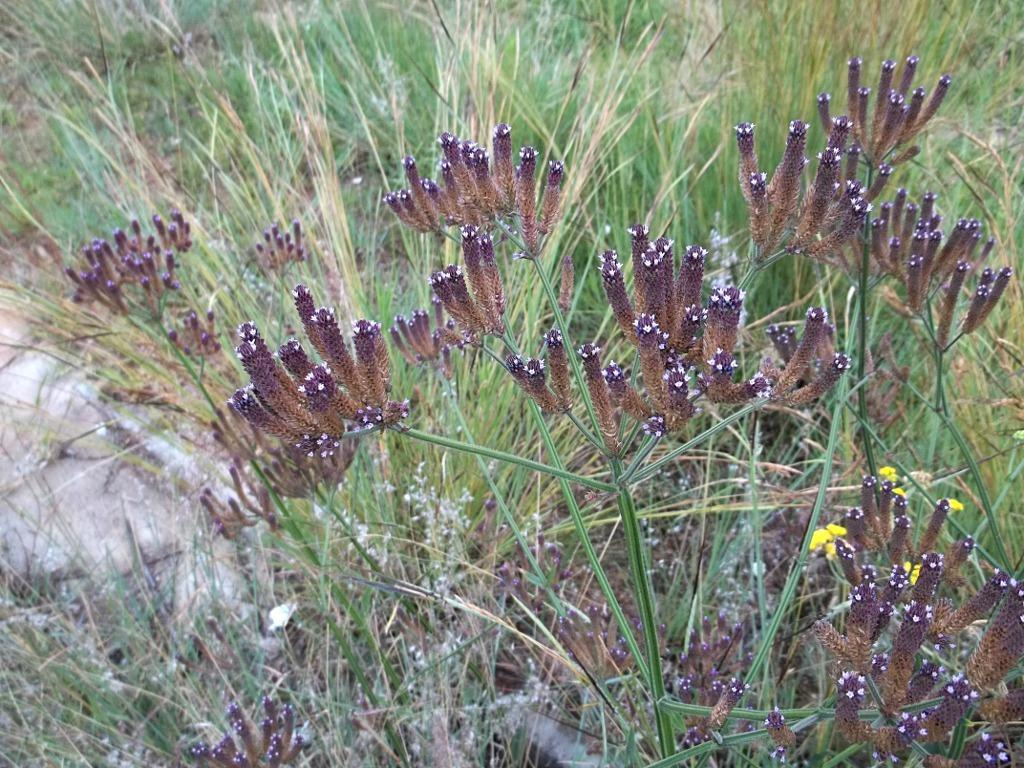What type of vegetation is present in the image? There is grass in the image. What other natural elements can be seen in the image? There are flowers in the image. What colors are the flowers? The flowers are pink, brown, white, and yellow in color. Where is the white-colored object located in the image? The white-colored object is on the left side of the image. How does the sand interact with the tramp in the image? There is no sand or tramp present in the image. What is the zinc used for in the image? There is no zinc present in the image. 